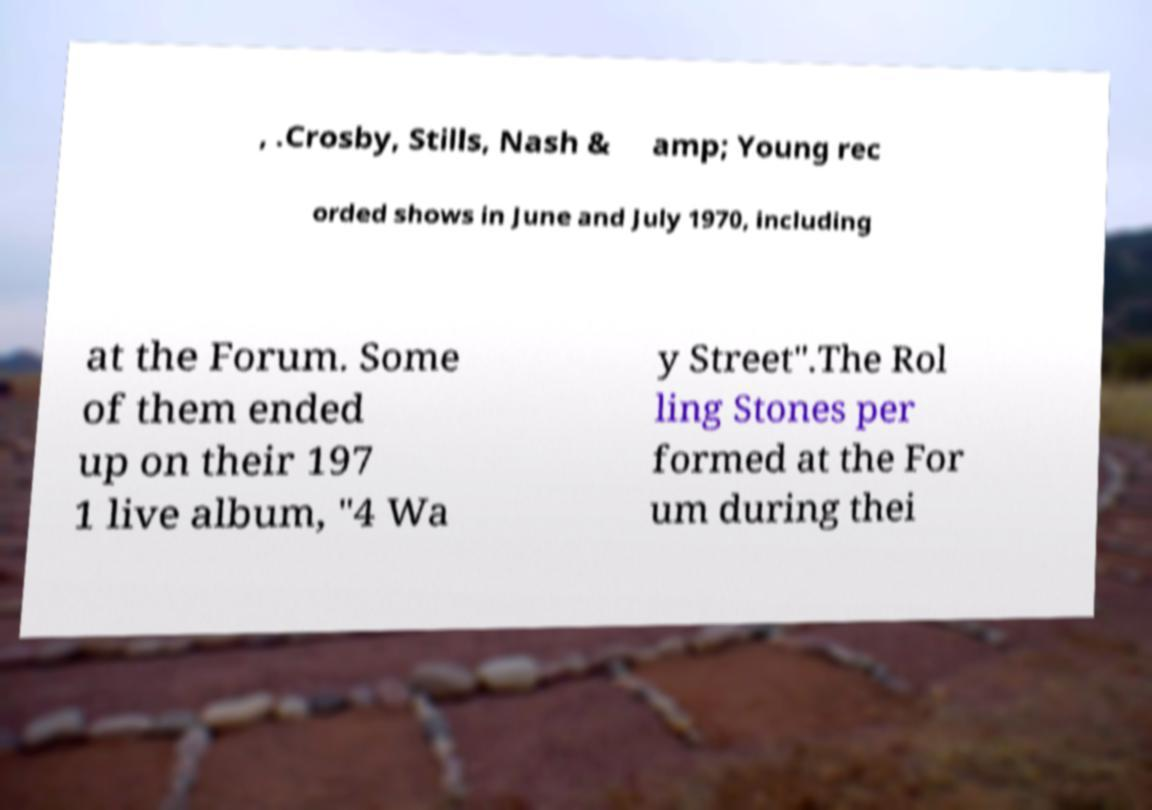What messages or text are displayed in this image? I need them in a readable, typed format. , .Crosby, Stills, Nash & amp; Young rec orded shows in June and July 1970, including at the Forum. Some of them ended up on their 197 1 live album, "4 Wa y Street".The Rol ling Stones per formed at the For um during thei 